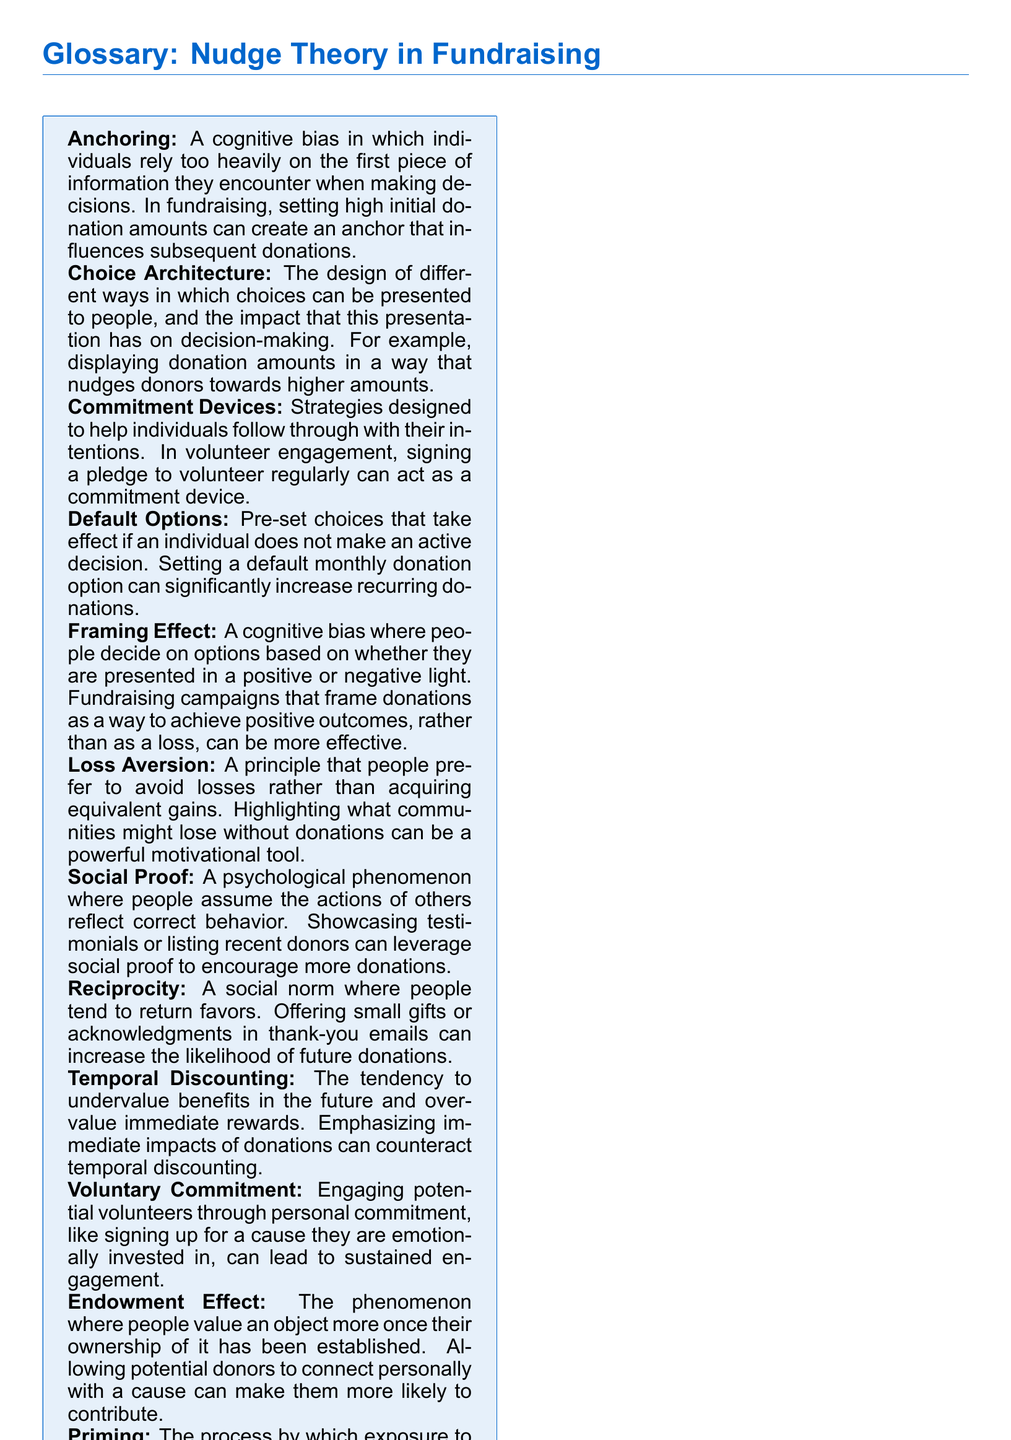What is the definition of Anchoring? The document defines Anchoring as a cognitive bias in which individuals rely too heavily on the first piece of information they encounter when making decisions.
Answer: Cognitive bias What are Default Options? Default Options are pre-set choices that take effect if an individual does not make an active decision.
Answer: Pre-set choices What effect does Loss Aversion have? The document explains that Loss Aversion is a principle where people prefer to avoid losses rather than acquiring equivalent gains.
Answer: Avoid losses What is an example of a Commitment Device? The document mentions signing a pledge to volunteer regularly as an example of a Commitment Device.
Answer: Signing a pledge How does the Framing Effect influence decisions? The Framing Effect influences decisions based on whether options are presented in a positive or negative light, impacting fundraising effectiveness.
Answer: Positive or negative light What concept involves the tendency to undervalue future benefits? Temporal Discounting describes the tendency to undervalue benefits in the future and overvalue immediate rewards.
Answer: Temporal Discounting What is a strategy to leverage Social Proof in fundraising? Showcasing testimonials or listing recent donors can leverage Social Proof to encourage more donations.
Answer: Testimonials or listing donors What does Priming influence in donation behavior? Priming influences responses to subsequent stimuli, like donation behavior, by exposing donors to related stories or images.
Answer: Donation behavior What do Suggested Donation Levels do? Suggested Donation Levels set specific donation amounts on fundraising platforms, guiding donors towards chosen levels.
Answer: Guide donors What role does Reciprocity play in fundraising? Reciprocity is a social norm where people tend to return favors, which can increase the likelihood of future donations.
Answer: Return favors 